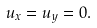Convert formula to latex. <formula><loc_0><loc_0><loc_500><loc_500>u _ { x } = u _ { y } = 0 .</formula> 